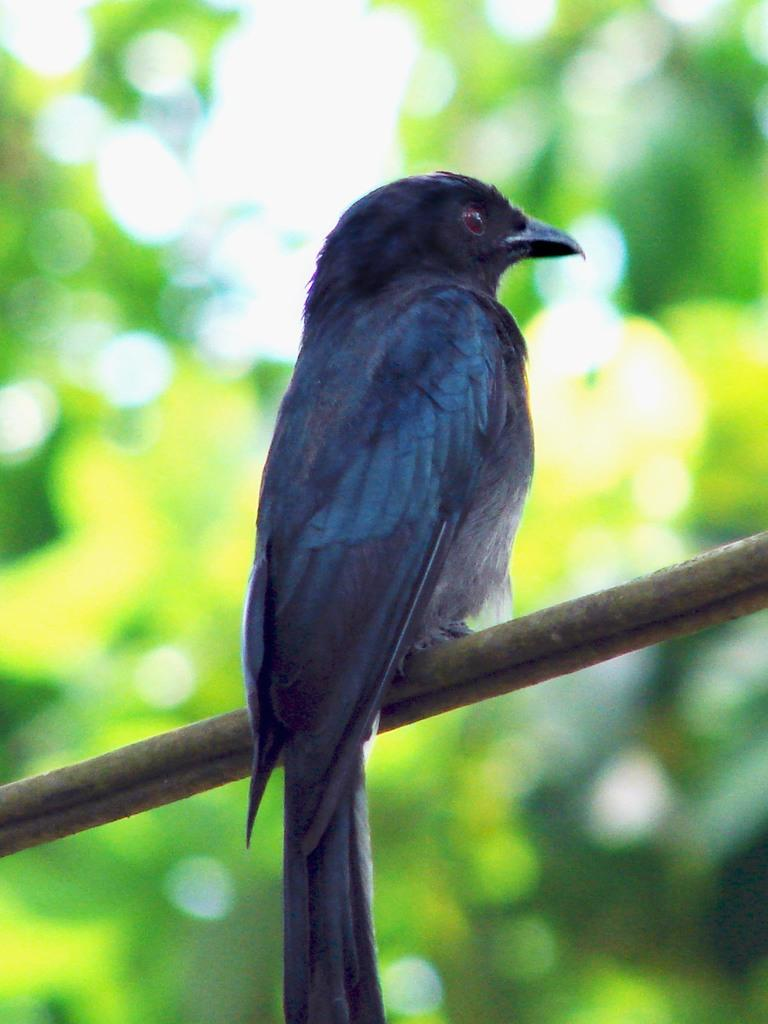What type of animal is in the image? There is a bird in the image. What is the bird sitting on? The bird is sitting on a wooden stick. Can you describe the background of the image? The background of the image is blurry. What type of clam is visible in the image? There is no clam present in the image; it features a bird sitting on a wooden stick. How does the spoon interact with the bird in the image? There is no spoon present in the image, so it cannot interact with the bird. 